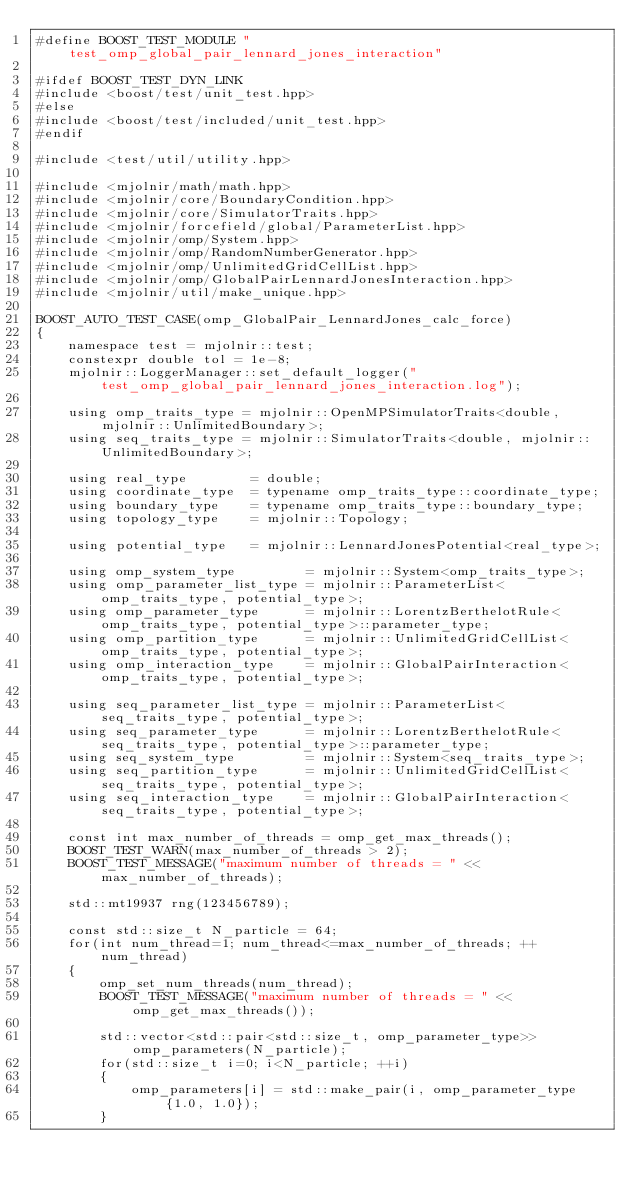<code> <loc_0><loc_0><loc_500><loc_500><_C++_>#define BOOST_TEST_MODULE "test_omp_global_pair_lennard_jones_interaction"

#ifdef BOOST_TEST_DYN_LINK
#include <boost/test/unit_test.hpp>
#else
#include <boost/test/included/unit_test.hpp>
#endif

#include <test/util/utility.hpp>

#include <mjolnir/math/math.hpp>
#include <mjolnir/core/BoundaryCondition.hpp>
#include <mjolnir/core/SimulatorTraits.hpp>
#include <mjolnir/forcefield/global/ParameterList.hpp>
#include <mjolnir/omp/System.hpp>
#include <mjolnir/omp/RandomNumberGenerator.hpp>
#include <mjolnir/omp/UnlimitedGridCellList.hpp>
#include <mjolnir/omp/GlobalPairLennardJonesInteraction.hpp>
#include <mjolnir/util/make_unique.hpp>

BOOST_AUTO_TEST_CASE(omp_GlobalPair_LennardJones_calc_force)
{
    namespace test = mjolnir::test;
    constexpr double tol = 1e-8;
    mjolnir::LoggerManager::set_default_logger("test_omp_global_pair_lennard_jones_interaction.log");

    using omp_traits_type = mjolnir::OpenMPSimulatorTraits<double, mjolnir::UnlimitedBoundary>;
    using seq_traits_type = mjolnir::SimulatorTraits<double, mjolnir::UnlimitedBoundary>;

    using real_type        = double;
    using coordinate_type  = typename omp_traits_type::coordinate_type;
    using boundary_type    = typename omp_traits_type::boundary_type;
    using topology_type    = mjolnir::Topology;

    using potential_type   = mjolnir::LennardJonesPotential<real_type>;

    using omp_system_type         = mjolnir::System<omp_traits_type>;
    using omp_parameter_list_type = mjolnir::ParameterList<omp_traits_type, potential_type>;
    using omp_parameter_type      = mjolnir::LorentzBerthelotRule<omp_traits_type, potential_type>::parameter_type;
    using omp_partition_type      = mjolnir::UnlimitedGridCellList<omp_traits_type, potential_type>;
    using omp_interaction_type    = mjolnir::GlobalPairInteraction<omp_traits_type, potential_type>;

    using seq_parameter_list_type = mjolnir::ParameterList<seq_traits_type, potential_type>;
    using seq_parameter_type      = mjolnir::LorentzBerthelotRule<seq_traits_type, potential_type>::parameter_type;
    using seq_system_type         = mjolnir::System<seq_traits_type>;
    using seq_partition_type      = mjolnir::UnlimitedGridCellList<seq_traits_type, potential_type>;
    using seq_interaction_type    = mjolnir::GlobalPairInteraction<seq_traits_type, potential_type>;

    const int max_number_of_threads = omp_get_max_threads();
    BOOST_TEST_WARN(max_number_of_threads > 2);
    BOOST_TEST_MESSAGE("maximum number of threads = " << max_number_of_threads);

    std::mt19937 rng(123456789);

    const std::size_t N_particle = 64;
    for(int num_thread=1; num_thread<=max_number_of_threads; ++num_thread)
    {
        omp_set_num_threads(num_thread);
        BOOST_TEST_MESSAGE("maximum number of threads = " << omp_get_max_threads());

        std::vector<std::pair<std::size_t, omp_parameter_type>> omp_parameters(N_particle);
        for(std::size_t i=0; i<N_particle; ++i)
        {
            omp_parameters[i] = std::make_pair(i, omp_parameter_type{1.0, 1.0});
        }</code> 